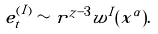Convert formula to latex. <formula><loc_0><loc_0><loc_500><loc_500>e ^ { ( I ) } _ { t } \sim r ^ { z - 3 } w ^ { I } ( x ^ { \alpha } ) .</formula> 